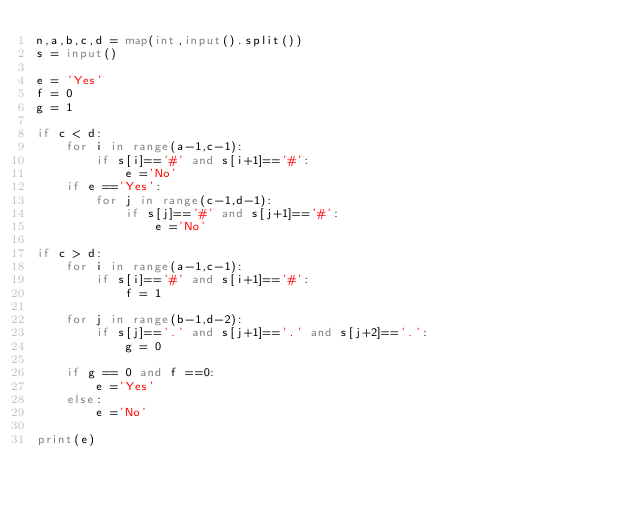Convert code to text. <code><loc_0><loc_0><loc_500><loc_500><_Python_>n,a,b,c,d = map(int,input().split())
s = input()

e = 'Yes'
f = 0
g = 1

if c < d:
    for i in range(a-1,c-1):
        if s[i]=='#' and s[i+1]=='#':
            e ='No'
    if e =='Yes':
        for j in range(c-1,d-1):
            if s[j]=='#' and s[j+1]=='#':
                e ='No'
                        
if c > d:
    for i in range(a-1,c-1):
        if s[i]=='#' and s[i+1]=='#':
            f = 1
    
    for j in range(b-1,d-2):
        if s[j]=='.' and s[j+1]=='.' and s[j+2]=='.':
            g = 0

    if g == 0 and f ==0:
        e ='Yes'
    else:
        e ='No'
            
print(e)          </code> 